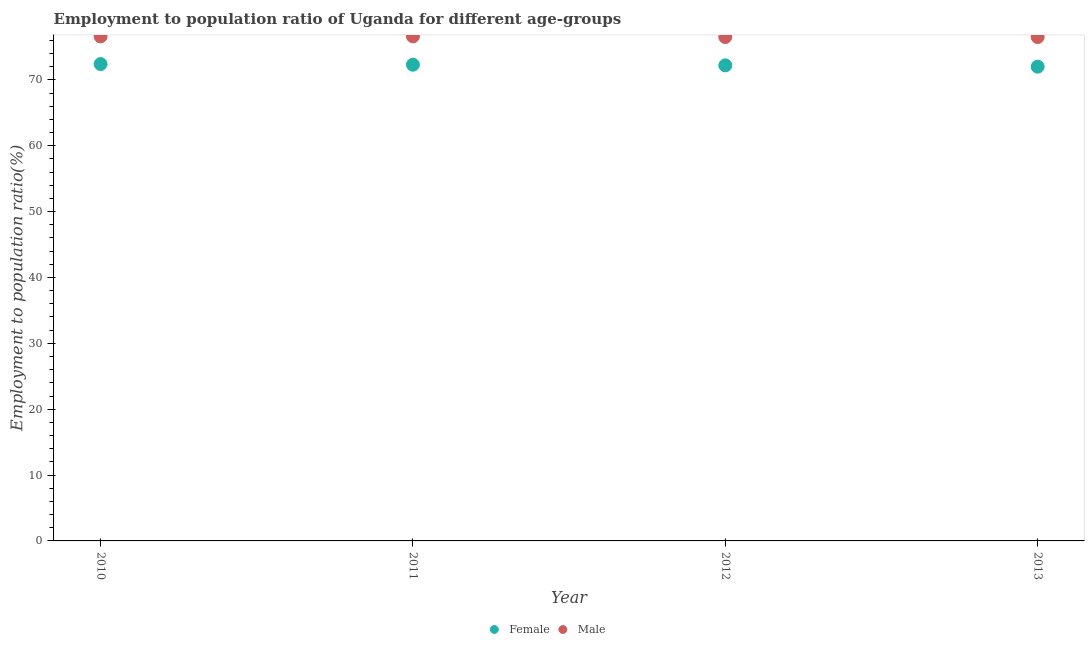How many different coloured dotlines are there?
Your answer should be very brief. 2. What is the employment to population ratio(male) in 2012?
Offer a terse response. 76.5. Across all years, what is the maximum employment to population ratio(female)?
Offer a terse response. 72.4. Across all years, what is the minimum employment to population ratio(male)?
Your response must be concise. 76.5. In which year was the employment to population ratio(female) minimum?
Your answer should be compact. 2013. What is the total employment to population ratio(male) in the graph?
Provide a short and direct response. 306.2. What is the difference between the employment to population ratio(female) in 2011 and that in 2013?
Provide a short and direct response. 0.3. What is the difference between the employment to population ratio(female) in 2010 and the employment to population ratio(male) in 2013?
Your answer should be compact. -4.1. What is the average employment to population ratio(male) per year?
Your response must be concise. 76.55. In the year 2012, what is the difference between the employment to population ratio(female) and employment to population ratio(male)?
Your answer should be compact. -4.3. What is the ratio of the employment to population ratio(female) in 2011 to that in 2013?
Provide a short and direct response. 1. Is the employment to population ratio(male) in 2010 less than that in 2011?
Keep it short and to the point. No. What is the difference between the highest and the second highest employment to population ratio(male)?
Give a very brief answer. 0. What is the difference between the highest and the lowest employment to population ratio(male)?
Provide a succinct answer. 0.1. Is the sum of the employment to population ratio(female) in 2012 and 2013 greater than the maximum employment to population ratio(male) across all years?
Your answer should be compact. Yes. Is the employment to population ratio(female) strictly less than the employment to population ratio(male) over the years?
Provide a succinct answer. Yes. How many years are there in the graph?
Offer a very short reply. 4. How many legend labels are there?
Provide a short and direct response. 2. How are the legend labels stacked?
Ensure brevity in your answer.  Horizontal. What is the title of the graph?
Your answer should be very brief. Employment to population ratio of Uganda for different age-groups. What is the label or title of the X-axis?
Ensure brevity in your answer.  Year. What is the label or title of the Y-axis?
Your answer should be compact. Employment to population ratio(%). What is the Employment to population ratio(%) of Female in 2010?
Make the answer very short. 72.4. What is the Employment to population ratio(%) of Male in 2010?
Your answer should be compact. 76.6. What is the Employment to population ratio(%) of Female in 2011?
Your answer should be very brief. 72.3. What is the Employment to population ratio(%) in Male in 2011?
Your response must be concise. 76.6. What is the Employment to population ratio(%) of Female in 2012?
Provide a succinct answer. 72.2. What is the Employment to population ratio(%) of Male in 2012?
Provide a succinct answer. 76.5. What is the Employment to population ratio(%) of Male in 2013?
Give a very brief answer. 76.5. Across all years, what is the maximum Employment to population ratio(%) in Female?
Your answer should be very brief. 72.4. Across all years, what is the maximum Employment to population ratio(%) in Male?
Make the answer very short. 76.6. Across all years, what is the minimum Employment to population ratio(%) in Male?
Offer a very short reply. 76.5. What is the total Employment to population ratio(%) in Female in the graph?
Provide a succinct answer. 288.9. What is the total Employment to population ratio(%) in Male in the graph?
Offer a terse response. 306.2. What is the difference between the Employment to population ratio(%) in Male in 2010 and that in 2011?
Your response must be concise. 0. What is the difference between the Employment to population ratio(%) of Female in 2010 and that in 2012?
Offer a terse response. 0.2. What is the difference between the Employment to population ratio(%) of Male in 2010 and that in 2013?
Offer a terse response. 0.1. What is the difference between the Employment to population ratio(%) in Male in 2011 and that in 2012?
Make the answer very short. 0.1. What is the difference between the Employment to population ratio(%) of Female in 2011 and that in 2013?
Ensure brevity in your answer.  0.3. What is the difference between the Employment to population ratio(%) of Male in 2011 and that in 2013?
Provide a short and direct response. 0.1. What is the difference between the Employment to population ratio(%) of Female in 2012 and that in 2013?
Offer a terse response. 0.2. What is the difference between the Employment to population ratio(%) in Female in 2010 and the Employment to population ratio(%) in Male in 2013?
Your response must be concise. -4.1. What is the average Employment to population ratio(%) in Female per year?
Make the answer very short. 72.22. What is the average Employment to population ratio(%) in Male per year?
Offer a very short reply. 76.55. In the year 2010, what is the difference between the Employment to population ratio(%) in Female and Employment to population ratio(%) in Male?
Ensure brevity in your answer.  -4.2. What is the ratio of the Employment to population ratio(%) of Female in 2010 to that in 2011?
Provide a succinct answer. 1. What is the ratio of the Employment to population ratio(%) of Female in 2010 to that in 2012?
Your answer should be compact. 1. What is the ratio of the Employment to population ratio(%) of Female in 2010 to that in 2013?
Your response must be concise. 1.01. What is the ratio of the Employment to population ratio(%) of Female in 2011 to that in 2013?
Make the answer very short. 1. What is the difference between the highest and the second highest Employment to population ratio(%) in Female?
Your answer should be very brief. 0.1. What is the difference between the highest and the lowest Employment to population ratio(%) of Female?
Your answer should be very brief. 0.4. What is the difference between the highest and the lowest Employment to population ratio(%) in Male?
Your response must be concise. 0.1. 